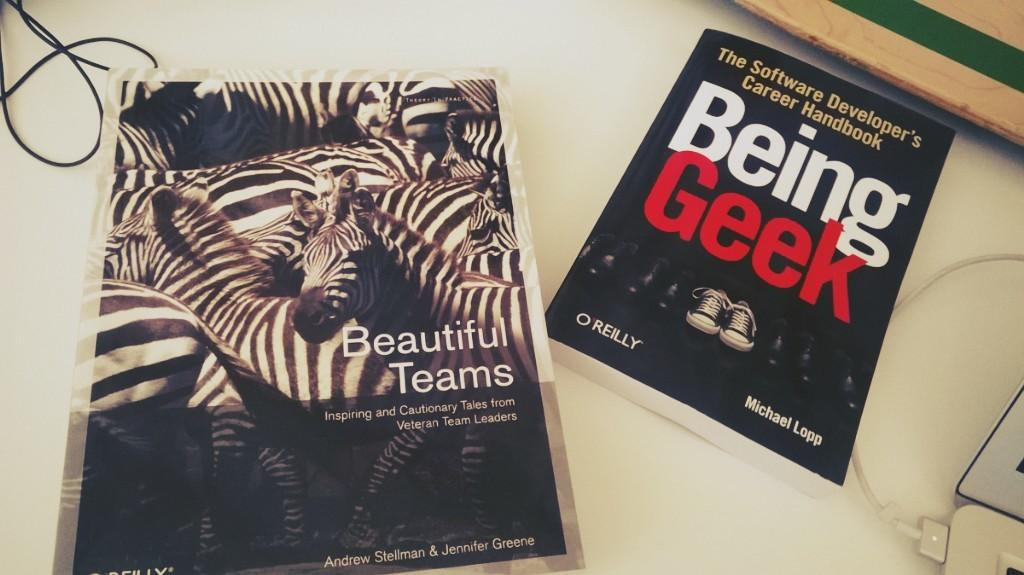<image>
Offer a succinct explanation of the picture presented. A book called Being Geek sits on a white table. 